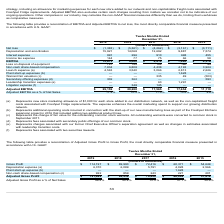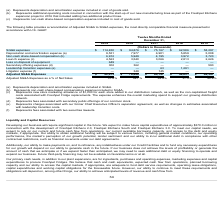From Freshpet's financial document, What are the 3 expenses shown in the table? The document contains multiple relevant values: Depreciation expense, Plant start-up expense, Non-cash share-based compensation expense. From the document: "Depreciation expense (a) 6,370 6,089 5,791 4,028 2,566 Plant start-up expense (b) — — — 1,628 — (c) Represents non-cash share-based compensation expen..." Also, What is the gross profit for each financial year end shown in the table (in chronological order)? The document contains multiple relevant values: $54,649, $60,371, $72,416, $89,990, $114,197 (in thousands). From the document: "Gross Profit $ 114,197 $ 89,990 $ 72,416 $ 60,371 $ 54,649 Gross Profit $ 114,197 $ 89,990 $ 72,416 $ 60,371 $ 54,649 Gross Profit $ 114,197 $ 89,990 ..." Also, What is the adjusted gross profit for each financial year end shown in the table (in chronological order)? The document contains multiple relevant values: $57,416, $66,248, $78,450, $96,938, $121,489 (in thousands). From the document: "Adjusted Gross Profit $ 121,489 $ 96,938 $ 78,450 $ 66,248 $ 57,416 oss Profit $ 121,489 $ 96,938 $ 78,450 $ 66,248 $ 57,416 Adjusted Gross Profit $ 1..." Also, can you calculate: What is the percentage change in depreciation expense from 2018 to 2019? To answer this question, I need to perform calculations using the financial data. The calculation is: (6,370-6,089)/6,089, which equals 4.61 (percentage). This is based on the information: "Depreciation expense (a) 6,370 6,089 5,791 4,028 2,566 Depreciation expense (a) 6,370 6,089 5,791 4,028 2,566..." The key data points involved are: 6,089, 6,370. Also, can you calculate: What is the percentage change in non-cash share-based compensation expense from 2018 to 2019? To answer this question, I need to perform calculations using the financial data. The calculation is: (922-859)/859, which equals 7.33 (percentage). This is based on the information: "Non-cash share-based compensation (c) 922 859 243 221 201 Non-cash share-based compensation (c) 922 859 243 221 201..." The key data points involved are: 859, 922. Also, can you calculate: What is the percentage change in adjusted gross profit from 2018 to 2019? To answer this question, I need to perform calculations using the financial data. The calculation is: (121,489-96,938)/96,938, which equals 25.33 (percentage). This is based on the information: "Adjusted Gross Profit $ 121,489 $ 96,938 $ 78,450 $ 66,248 $ 57,416 Adjusted Gross Profit $ 121,489 $ 96,938 $ 78,450 $ 66,248 $ 57,416..." The key data points involved are: 121,489, 96,938. 